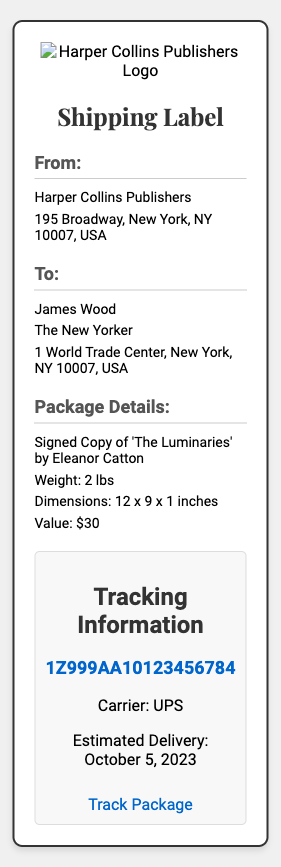What is the name of the sender? The sender's name is stated as Harper Collins Publishers in the document.
Answer: Harper Collins Publishers Who is the recipient of the shipping label? The document specifies the recipient as James Wood.
Answer: James Wood What is the estimated delivery date? The estimated delivery date is provided in the tracking section of the document.
Answer: October 5, 2023 What is the weight of the package? The package's weight is included in the package details section of the document.
Answer: 2 lbs What is the tracking number? The tracking number is presented in the tracking information section of the document.
Answer: 1Z999AA10123456784 What is the value of the item being shipped? The document lists the item's value in the package details section.
Answer: $30 What is the shipping carrier? The shipping carrier is mentioned in the tracking information section of the document.
Answer: UPS What are the dimensions of the package? The package dimensions are provided in the package details section of the document.
Answer: 12 x 9 x 1 inches What type of item is being shipped? The document identifies the item shipped in the package details section.
Answer: Signed Copy of 'The Luminaries' by Eleanor Catton 